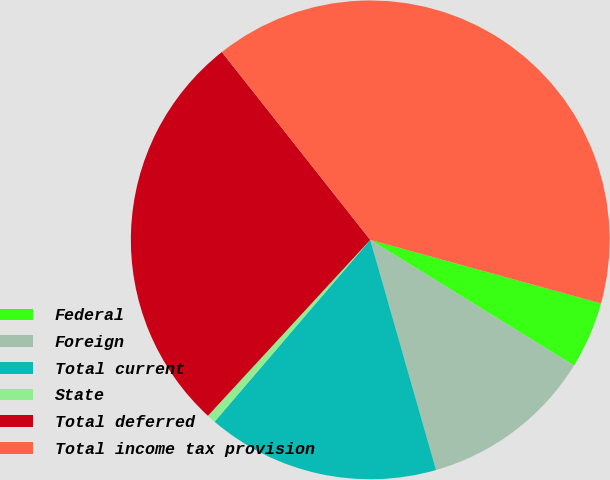Convert chart to OTSL. <chart><loc_0><loc_0><loc_500><loc_500><pie_chart><fcel>Federal<fcel>Foreign<fcel>Total current<fcel>State<fcel>Total deferred<fcel>Total income tax provision<nl><fcel>4.52%<fcel>11.77%<fcel>15.7%<fcel>0.59%<fcel>27.5%<fcel>39.92%<nl></chart> 